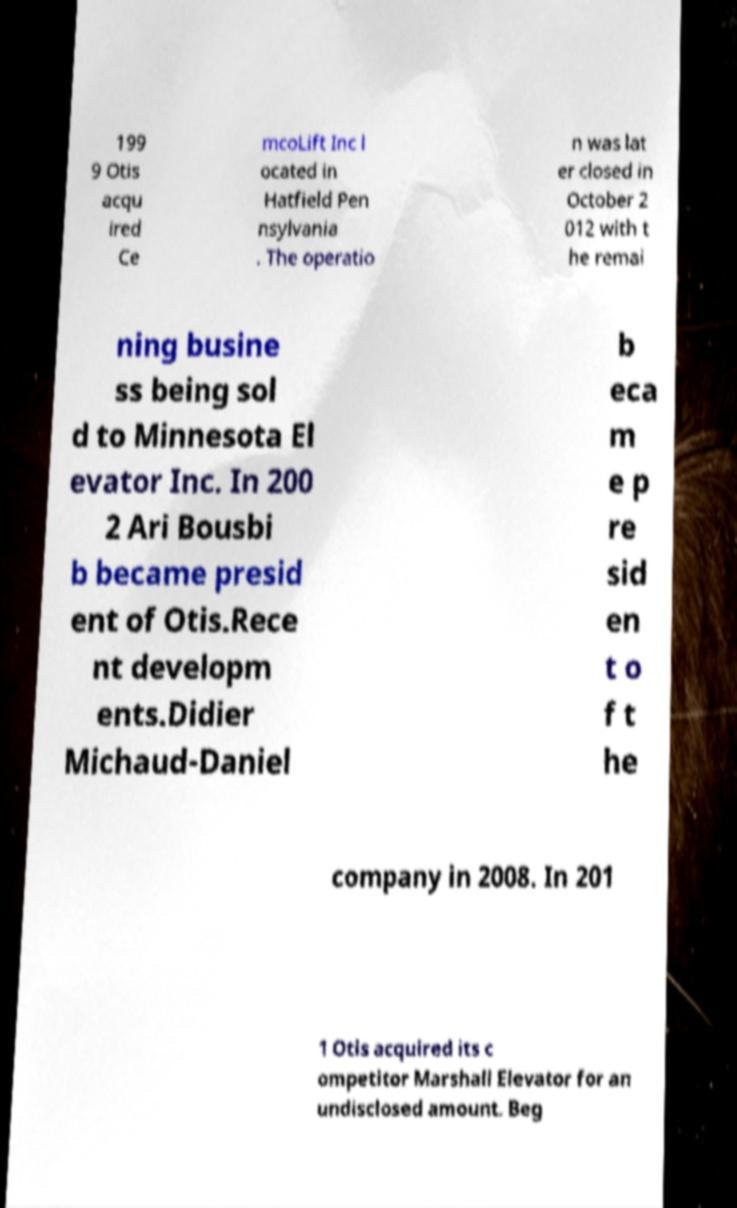What messages or text are displayed in this image? I need them in a readable, typed format. 199 9 Otis acqu ired Ce mcoLift Inc l ocated in Hatfield Pen nsylvania . The operatio n was lat er closed in October 2 012 with t he remai ning busine ss being sol d to Minnesota El evator Inc. In 200 2 Ari Bousbi b became presid ent of Otis.Rece nt developm ents.Didier Michaud-Daniel b eca m e p re sid en t o f t he company in 2008. In 201 1 Otis acquired its c ompetitor Marshall Elevator for an undisclosed amount. Beg 